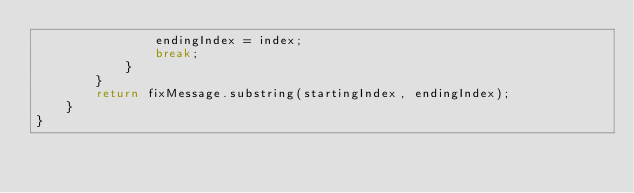<code> <loc_0><loc_0><loc_500><loc_500><_Java_>                endingIndex = index;
                break;
            }
        }
        return fixMessage.substring(startingIndex, endingIndex);
    }
}
</code> 